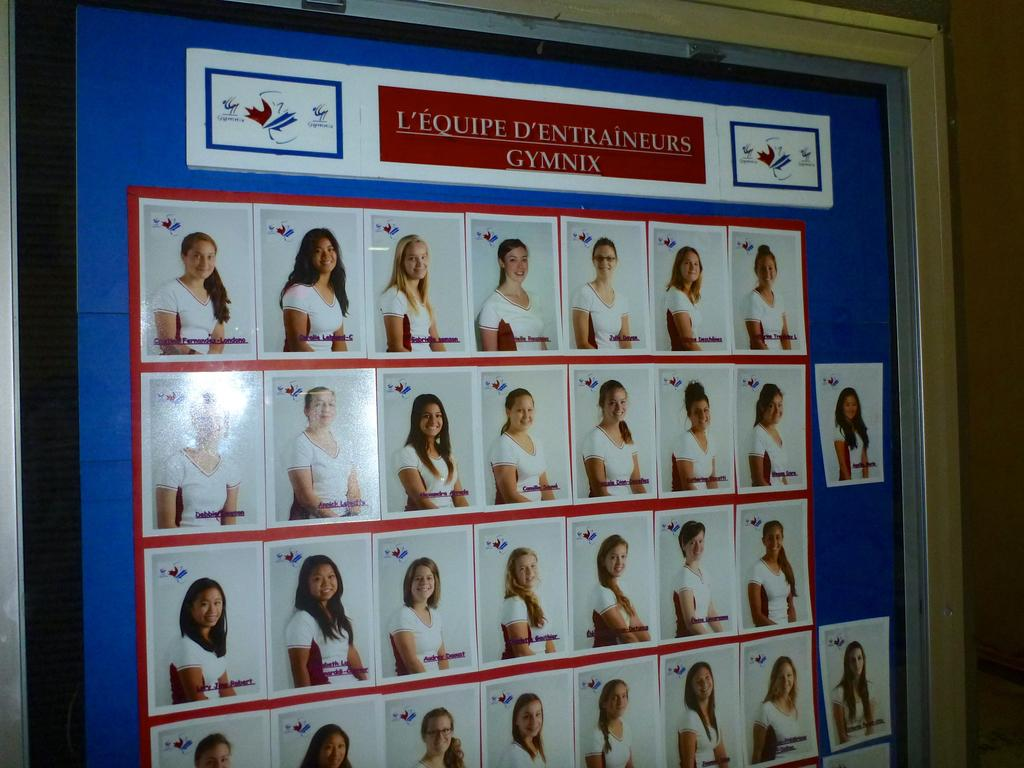What is the main subject of the image? The main subject of the image is a board with photos. What can be seen in the photos on the board? The photos have images of women. What are the women wearing in the photos? The women are wearing white clothes. What expression do the women have in the photos? The women are smiling. What type of zipper can be seen on the women's clothes in the image? There is no zipper visible on the women's clothes in the image; they are wearing white clothes without any visible zippers. 